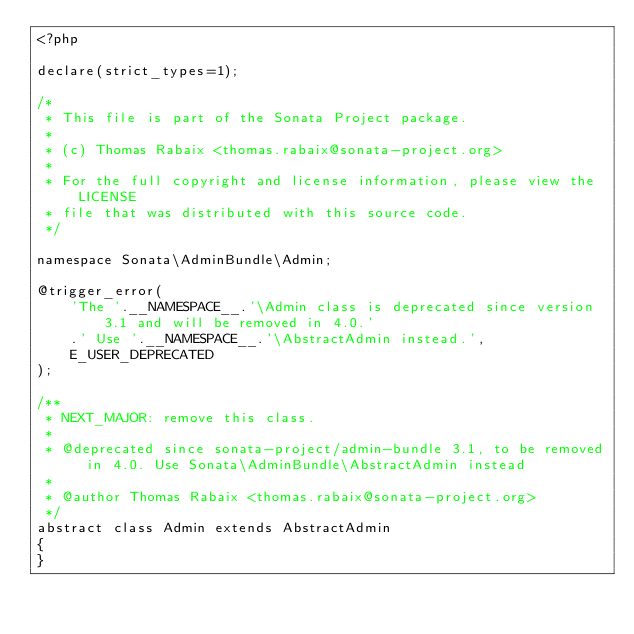Convert code to text. <code><loc_0><loc_0><loc_500><loc_500><_PHP_><?php

declare(strict_types=1);

/*
 * This file is part of the Sonata Project package.
 *
 * (c) Thomas Rabaix <thomas.rabaix@sonata-project.org>
 *
 * For the full copyright and license information, please view the LICENSE
 * file that was distributed with this source code.
 */

namespace Sonata\AdminBundle\Admin;

@trigger_error(
    'The '.__NAMESPACE__.'\Admin class is deprecated since version 3.1 and will be removed in 4.0.'
    .' Use '.__NAMESPACE__.'\AbstractAdmin instead.',
    E_USER_DEPRECATED
);

/**
 * NEXT_MAJOR: remove this class.
 *
 * @deprecated since sonata-project/admin-bundle 3.1, to be removed in 4.0. Use Sonata\AdminBundle\AbstractAdmin instead
 *
 * @author Thomas Rabaix <thomas.rabaix@sonata-project.org>
 */
abstract class Admin extends AbstractAdmin
{
}
</code> 